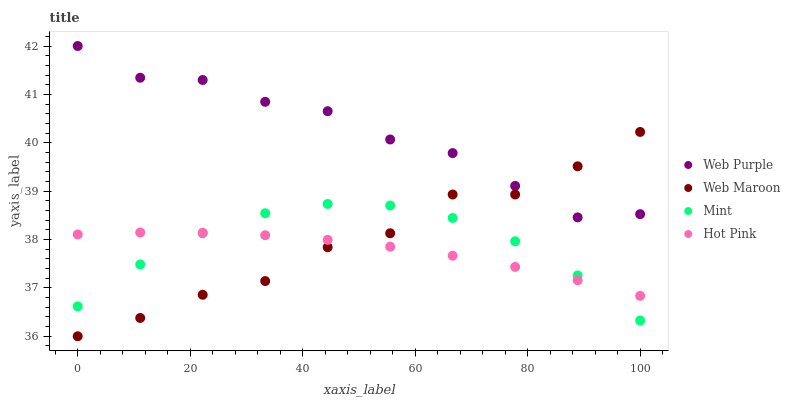Does Hot Pink have the minimum area under the curve?
Answer yes or no. Yes. Does Web Purple have the maximum area under the curve?
Answer yes or no. Yes. Does Web Purple have the minimum area under the curve?
Answer yes or no. No. Does Hot Pink have the maximum area under the curve?
Answer yes or no. No. Is Hot Pink the smoothest?
Answer yes or no. Yes. Is Web Maroon the roughest?
Answer yes or no. Yes. Is Web Purple the smoothest?
Answer yes or no. No. Is Web Purple the roughest?
Answer yes or no. No. Does Web Maroon have the lowest value?
Answer yes or no. Yes. Does Hot Pink have the lowest value?
Answer yes or no. No. Does Web Purple have the highest value?
Answer yes or no. Yes. Does Hot Pink have the highest value?
Answer yes or no. No. Is Mint less than Web Purple?
Answer yes or no. Yes. Is Web Purple greater than Hot Pink?
Answer yes or no. Yes. Does Web Maroon intersect Web Purple?
Answer yes or no. Yes. Is Web Maroon less than Web Purple?
Answer yes or no. No. Is Web Maroon greater than Web Purple?
Answer yes or no. No. Does Mint intersect Web Purple?
Answer yes or no. No. 